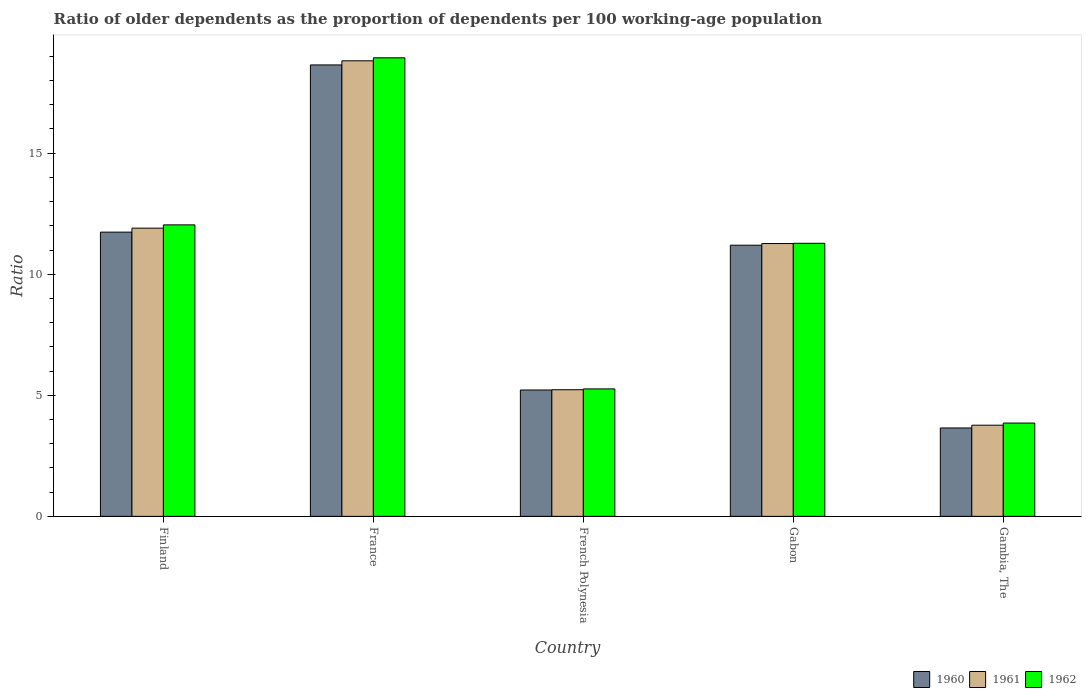How many different coloured bars are there?
Offer a terse response. 3. How many groups of bars are there?
Your answer should be compact. 5. Are the number of bars on each tick of the X-axis equal?
Your answer should be very brief. Yes. How many bars are there on the 5th tick from the left?
Provide a succinct answer. 3. How many bars are there on the 2nd tick from the right?
Your answer should be compact. 3. In how many cases, is the number of bars for a given country not equal to the number of legend labels?
Your response must be concise. 0. What is the age dependency ratio(old) in 1960 in France?
Ensure brevity in your answer.  18.65. Across all countries, what is the maximum age dependency ratio(old) in 1961?
Your answer should be compact. 18.82. Across all countries, what is the minimum age dependency ratio(old) in 1961?
Make the answer very short. 3.77. In which country was the age dependency ratio(old) in 1961 minimum?
Your answer should be compact. Gambia, The. What is the total age dependency ratio(old) in 1960 in the graph?
Ensure brevity in your answer.  50.45. What is the difference between the age dependency ratio(old) in 1961 in French Polynesia and that in Gabon?
Your response must be concise. -6.04. What is the difference between the age dependency ratio(old) in 1961 in Gabon and the age dependency ratio(old) in 1962 in Finland?
Offer a very short reply. -0.77. What is the average age dependency ratio(old) in 1961 per country?
Offer a very short reply. 10.2. What is the difference between the age dependency ratio(old) of/in 1961 and age dependency ratio(old) of/in 1960 in Gambia, The?
Provide a succinct answer. 0.11. What is the ratio of the age dependency ratio(old) in 1960 in France to that in Gabon?
Offer a very short reply. 1.66. What is the difference between the highest and the second highest age dependency ratio(old) in 1961?
Your response must be concise. -7.55. What is the difference between the highest and the lowest age dependency ratio(old) in 1962?
Offer a very short reply. 15.09. In how many countries, is the age dependency ratio(old) in 1962 greater than the average age dependency ratio(old) in 1962 taken over all countries?
Keep it short and to the point. 3. What does the 2nd bar from the left in Finland represents?
Your response must be concise. 1961. What does the 3rd bar from the right in French Polynesia represents?
Your answer should be very brief. 1960. Is it the case that in every country, the sum of the age dependency ratio(old) in 1960 and age dependency ratio(old) in 1961 is greater than the age dependency ratio(old) in 1962?
Provide a succinct answer. Yes. How many bars are there?
Provide a short and direct response. 15. Are all the bars in the graph horizontal?
Ensure brevity in your answer.  No. What is the difference between two consecutive major ticks on the Y-axis?
Your answer should be very brief. 5. Are the values on the major ticks of Y-axis written in scientific E-notation?
Your response must be concise. No. Does the graph contain any zero values?
Your answer should be very brief. No. How many legend labels are there?
Your answer should be very brief. 3. How are the legend labels stacked?
Offer a terse response. Horizontal. What is the title of the graph?
Keep it short and to the point. Ratio of older dependents as the proportion of dependents per 100 working-age population. What is the label or title of the Y-axis?
Keep it short and to the point. Ratio. What is the Ratio of 1960 in Finland?
Give a very brief answer. 11.74. What is the Ratio of 1961 in Finland?
Keep it short and to the point. 11.9. What is the Ratio of 1962 in Finland?
Give a very brief answer. 12.04. What is the Ratio in 1960 in France?
Offer a very short reply. 18.65. What is the Ratio in 1961 in France?
Offer a terse response. 18.82. What is the Ratio in 1962 in France?
Ensure brevity in your answer.  18.94. What is the Ratio in 1960 in French Polynesia?
Offer a very short reply. 5.22. What is the Ratio in 1961 in French Polynesia?
Your answer should be very brief. 5.23. What is the Ratio of 1962 in French Polynesia?
Your answer should be very brief. 5.26. What is the Ratio in 1960 in Gabon?
Ensure brevity in your answer.  11.2. What is the Ratio of 1961 in Gabon?
Offer a very short reply. 11.27. What is the Ratio in 1962 in Gabon?
Provide a short and direct response. 11.28. What is the Ratio of 1960 in Gambia, The?
Your response must be concise. 3.65. What is the Ratio of 1961 in Gambia, The?
Make the answer very short. 3.77. What is the Ratio in 1962 in Gambia, The?
Give a very brief answer. 3.85. Across all countries, what is the maximum Ratio of 1960?
Ensure brevity in your answer.  18.65. Across all countries, what is the maximum Ratio of 1961?
Your response must be concise. 18.82. Across all countries, what is the maximum Ratio in 1962?
Offer a terse response. 18.94. Across all countries, what is the minimum Ratio of 1960?
Offer a terse response. 3.65. Across all countries, what is the minimum Ratio of 1961?
Provide a succinct answer. 3.77. Across all countries, what is the minimum Ratio in 1962?
Ensure brevity in your answer.  3.85. What is the total Ratio of 1960 in the graph?
Offer a very short reply. 50.45. What is the total Ratio in 1961 in the graph?
Give a very brief answer. 50.98. What is the total Ratio in 1962 in the graph?
Your answer should be very brief. 51.38. What is the difference between the Ratio in 1960 in Finland and that in France?
Your answer should be compact. -6.91. What is the difference between the Ratio in 1961 in Finland and that in France?
Offer a very short reply. -6.91. What is the difference between the Ratio in 1962 in Finland and that in France?
Offer a terse response. -6.9. What is the difference between the Ratio in 1960 in Finland and that in French Polynesia?
Make the answer very short. 6.52. What is the difference between the Ratio in 1961 in Finland and that in French Polynesia?
Make the answer very short. 6.67. What is the difference between the Ratio of 1962 in Finland and that in French Polynesia?
Give a very brief answer. 6.78. What is the difference between the Ratio of 1960 in Finland and that in Gabon?
Provide a succinct answer. 0.54. What is the difference between the Ratio in 1961 in Finland and that in Gabon?
Give a very brief answer. 0.64. What is the difference between the Ratio in 1962 in Finland and that in Gabon?
Keep it short and to the point. 0.76. What is the difference between the Ratio in 1960 in Finland and that in Gambia, The?
Offer a terse response. 8.09. What is the difference between the Ratio in 1961 in Finland and that in Gambia, The?
Your answer should be very brief. 8.14. What is the difference between the Ratio in 1962 in Finland and that in Gambia, The?
Your answer should be compact. 8.19. What is the difference between the Ratio in 1960 in France and that in French Polynesia?
Your answer should be very brief. 13.43. What is the difference between the Ratio of 1961 in France and that in French Polynesia?
Your response must be concise. 13.59. What is the difference between the Ratio in 1962 in France and that in French Polynesia?
Ensure brevity in your answer.  13.68. What is the difference between the Ratio in 1960 in France and that in Gabon?
Give a very brief answer. 7.45. What is the difference between the Ratio of 1961 in France and that in Gabon?
Make the answer very short. 7.55. What is the difference between the Ratio in 1962 in France and that in Gabon?
Give a very brief answer. 7.66. What is the difference between the Ratio in 1960 in France and that in Gambia, The?
Your response must be concise. 15. What is the difference between the Ratio in 1961 in France and that in Gambia, The?
Make the answer very short. 15.05. What is the difference between the Ratio of 1962 in France and that in Gambia, The?
Offer a very short reply. 15.09. What is the difference between the Ratio in 1960 in French Polynesia and that in Gabon?
Offer a very short reply. -5.98. What is the difference between the Ratio of 1961 in French Polynesia and that in Gabon?
Keep it short and to the point. -6.04. What is the difference between the Ratio of 1962 in French Polynesia and that in Gabon?
Give a very brief answer. -6.01. What is the difference between the Ratio in 1960 in French Polynesia and that in Gambia, The?
Provide a succinct answer. 1.57. What is the difference between the Ratio of 1961 in French Polynesia and that in Gambia, The?
Make the answer very short. 1.46. What is the difference between the Ratio in 1962 in French Polynesia and that in Gambia, The?
Make the answer very short. 1.41. What is the difference between the Ratio in 1960 in Gabon and that in Gambia, The?
Provide a short and direct response. 7.55. What is the difference between the Ratio in 1961 in Gabon and that in Gambia, The?
Your response must be concise. 7.5. What is the difference between the Ratio of 1962 in Gabon and that in Gambia, The?
Your response must be concise. 7.42. What is the difference between the Ratio in 1960 in Finland and the Ratio in 1961 in France?
Give a very brief answer. -7.08. What is the difference between the Ratio of 1960 in Finland and the Ratio of 1962 in France?
Provide a succinct answer. -7.2. What is the difference between the Ratio in 1961 in Finland and the Ratio in 1962 in France?
Offer a terse response. -7.04. What is the difference between the Ratio of 1960 in Finland and the Ratio of 1961 in French Polynesia?
Provide a short and direct response. 6.51. What is the difference between the Ratio in 1960 in Finland and the Ratio in 1962 in French Polynesia?
Offer a very short reply. 6.48. What is the difference between the Ratio of 1961 in Finland and the Ratio of 1962 in French Polynesia?
Offer a terse response. 6.64. What is the difference between the Ratio of 1960 in Finland and the Ratio of 1961 in Gabon?
Offer a terse response. 0.47. What is the difference between the Ratio in 1960 in Finland and the Ratio in 1962 in Gabon?
Offer a terse response. 0.46. What is the difference between the Ratio in 1961 in Finland and the Ratio in 1962 in Gabon?
Make the answer very short. 0.63. What is the difference between the Ratio in 1960 in Finland and the Ratio in 1961 in Gambia, The?
Provide a short and direct response. 7.97. What is the difference between the Ratio in 1960 in Finland and the Ratio in 1962 in Gambia, The?
Make the answer very short. 7.89. What is the difference between the Ratio of 1961 in Finland and the Ratio of 1962 in Gambia, The?
Provide a short and direct response. 8.05. What is the difference between the Ratio of 1960 in France and the Ratio of 1961 in French Polynesia?
Your response must be concise. 13.42. What is the difference between the Ratio of 1960 in France and the Ratio of 1962 in French Polynesia?
Your answer should be very brief. 13.38. What is the difference between the Ratio in 1961 in France and the Ratio in 1962 in French Polynesia?
Offer a terse response. 13.55. What is the difference between the Ratio in 1960 in France and the Ratio in 1961 in Gabon?
Provide a succinct answer. 7.38. What is the difference between the Ratio in 1960 in France and the Ratio in 1962 in Gabon?
Offer a terse response. 7.37. What is the difference between the Ratio of 1961 in France and the Ratio of 1962 in Gabon?
Keep it short and to the point. 7.54. What is the difference between the Ratio of 1960 in France and the Ratio of 1961 in Gambia, The?
Offer a terse response. 14.88. What is the difference between the Ratio of 1960 in France and the Ratio of 1962 in Gambia, The?
Provide a succinct answer. 14.79. What is the difference between the Ratio of 1961 in France and the Ratio of 1962 in Gambia, The?
Provide a succinct answer. 14.96. What is the difference between the Ratio in 1960 in French Polynesia and the Ratio in 1961 in Gabon?
Your response must be concise. -6.05. What is the difference between the Ratio in 1960 in French Polynesia and the Ratio in 1962 in Gabon?
Provide a short and direct response. -6.06. What is the difference between the Ratio in 1961 in French Polynesia and the Ratio in 1962 in Gabon?
Give a very brief answer. -6.05. What is the difference between the Ratio in 1960 in French Polynesia and the Ratio in 1961 in Gambia, The?
Offer a terse response. 1.45. What is the difference between the Ratio in 1960 in French Polynesia and the Ratio in 1962 in Gambia, The?
Ensure brevity in your answer.  1.37. What is the difference between the Ratio in 1961 in French Polynesia and the Ratio in 1962 in Gambia, The?
Your response must be concise. 1.38. What is the difference between the Ratio of 1960 in Gabon and the Ratio of 1961 in Gambia, The?
Offer a very short reply. 7.43. What is the difference between the Ratio in 1960 in Gabon and the Ratio in 1962 in Gambia, The?
Provide a short and direct response. 7.35. What is the difference between the Ratio in 1961 in Gabon and the Ratio in 1962 in Gambia, The?
Your response must be concise. 7.42. What is the average Ratio in 1960 per country?
Make the answer very short. 10.09. What is the average Ratio of 1961 per country?
Your answer should be very brief. 10.2. What is the average Ratio in 1962 per country?
Make the answer very short. 10.28. What is the difference between the Ratio in 1960 and Ratio in 1961 in Finland?
Give a very brief answer. -0.16. What is the difference between the Ratio of 1960 and Ratio of 1962 in Finland?
Provide a succinct answer. -0.3. What is the difference between the Ratio in 1961 and Ratio in 1962 in Finland?
Your answer should be very brief. -0.14. What is the difference between the Ratio of 1960 and Ratio of 1961 in France?
Give a very brief answer. -0.17. What is the difference between the Ratio of 1960 and Ratio of 1962 in France?
Offer a terse response. -0.29. What is the difference between the Ratio in 1961 and Ratio in 1962 in France?
Your answer should be compact. -0.12. What is the difference between the Ratio in 1960 and Ratio in 1961 in French Polynesia?
Provide a short and direct response. -0.01. What is the difference between the Ratio of 1960 and Ratio of 1962 in French Polynesia?
Make the answer very short. -0.04. What is the difference between the Ratio of 1961 and Ratio of 1962 in French Polynesia?
Offer a very short reply. -0.03. What is the difference between the Ratio of 1960 and Ratio of 1961 in Gabon?
Your answer should be very brief. -0.07. What is the difference between the Ratio of 1960 and Ratio of 1962 in Gabon?
Provide a short and direct response. -0.08. What is the difference between the Ratio of 1961 and Ratio of 1962 in Gabon?
Your response must be concise. -0.01. What is the difference between the Ratio of 1960 and Ratio of 1961 in Gambia, The?
Keep it short and to the point. -0.11. What is the difference between the Ratio in 1960 and Ratio in 1962 in Gambia, The?
Make the answer very short. -0.2. What is the difference between the Ratio of 1961 and Ratio of 1962 in Gambia, The?
Your response must be concise. -0.09. What is the ratio of the Ratio of 1960 in Finland to that in France?
Offer a terse response. 0.63. What is the ratio of the Ratio in 1961 in Finland to that in France?
Give a very brief answer. 0.63. What is the ratio of the Ratio in 1962 in Finland to that in France?
Your answer should be compact. 0.64. What is the ratio of the Ratio of 1960 in Finland to that in French Polynesia?
Give a very brief answer. 2.25. What is the ratio of the Ratio in 1961 in Finland to that in French Polynesia?
Your response must be concise. 2.28. What is the ratio of the Ratio of 1962 in Finland to that in French Polynesia?
Give a very brief answer. 2.29. What is the ratio of the Ratio of 1960 in Finland to that in Gabon?
Your answer should be very brief. 1.05. What is the ratio of the Ratio of 1961 in Finland to that in Gabon?
Ensure brevity in your answer.  1.06. What is the ratio of the Ratio in 1962 in Finland to that in Gabon?
Provide a short and direct response. 1.07. What is the ratio of the Ratio in 1960 in Finland to that in Gambia, The?
Your answer should be very brief. 3.22. What is the ratio of the Ratio in 1961 in Finland to that in Gambia, The?
Ensure brevity in your answer.  3.16. What is the ratio of the Ratio of 1962 in Finland to that in Gambia, The?
Keep it short and to the point. 3.12. What is the ratio of the Ratio in 1960 in France to that in French Polynesia?
Your answer should be compact. 3.57. What is the ratio of the Ratio in 1961 in France to that in French Polynesia?
Keep it short and to the point. 3.6. What is the ratio of the Ratio in 1962 in France to that in French Polynesia?
Provide a succinct answer. 3.6. What is the ratio of the Ratio in 1960 in France to that in Gabon?
Keep it short and to the point. 1.67. What is the ratio of the Ratio of 1961 in France to that in Gabon?
Your answer should be very brief. 1.67. What is the ratio of the Ratio in 1962 in France to that in Gabon?
Your response must be concise. 1.68. What is the ratio of the Ratio of 1960 in France to that in Gambia, The?
Provide a short and direct response. 5.11. What is the ratio of the Ratio of 1961 in France to that in Gambia, The?
Your answer should be compact. 5. What is the ratio of the Ratio of 1962 in France to that in Gambia, The?
Your answer should be very brief. 4.92. What is the ratio of the Ratio in 1960 in French Polynesia to that in Gabon?
Provide a succinct answer. 0.47. What is the ratio of the Ratio in 1961 in French Polynesia to that in Gabon?
Offer a terse response. 0.46. What is the ratio of the Ratio in 1962 in French Polynesia to that in Gabon?
Make the answer very short. 0.47. What is the ratio of the Ratio of 1960 in French Polynesia to that in Gambia, The?
Your answer should be very brief. 1.43. What is the ratio of the Ratio in 1961 in French Polynesia to that in Gambia, The?
Make the answer very short. 1.39. What is the ratio of the Ratio in 1962 in French Polynesia to that in Gambia, The?
Offer a very short reply. 1.37. What is the ratio of the Ratio in 1960 in Gabon to that in Gambia, The?
Provide a succinct answer. 3.07. What is the ratio of the Ratio of 1961 in Gabon to that in Gambia, The?
Ensure brevity in your answer.  2.99. What is the ratio of the Ratio in 1962 in Gabon to that in Gambia, The?
Offer a very short reply. 2.93. What is the difference between the highest and the second highest Ratio in 1960?
Provide a short and direct response. 6.91. What is the difference between the highest and the second highest Ratio in 1961?
Your answer should be compact. 6.91. What is the difference between the highest and the second highest Ratio of 1962?
Keep it short and to the point. 6.9. What is the difference between the highest and the lowest Ratio in 1960?
Your answer should be very brief. 15. What is the difference between the highest and the lowest Ratio in 1961?
Ensure brevity in your answer.  15.05. What is the difference between the highest and the lowest Ratio in 1962?
Your answer should be very brief. 15.09. 